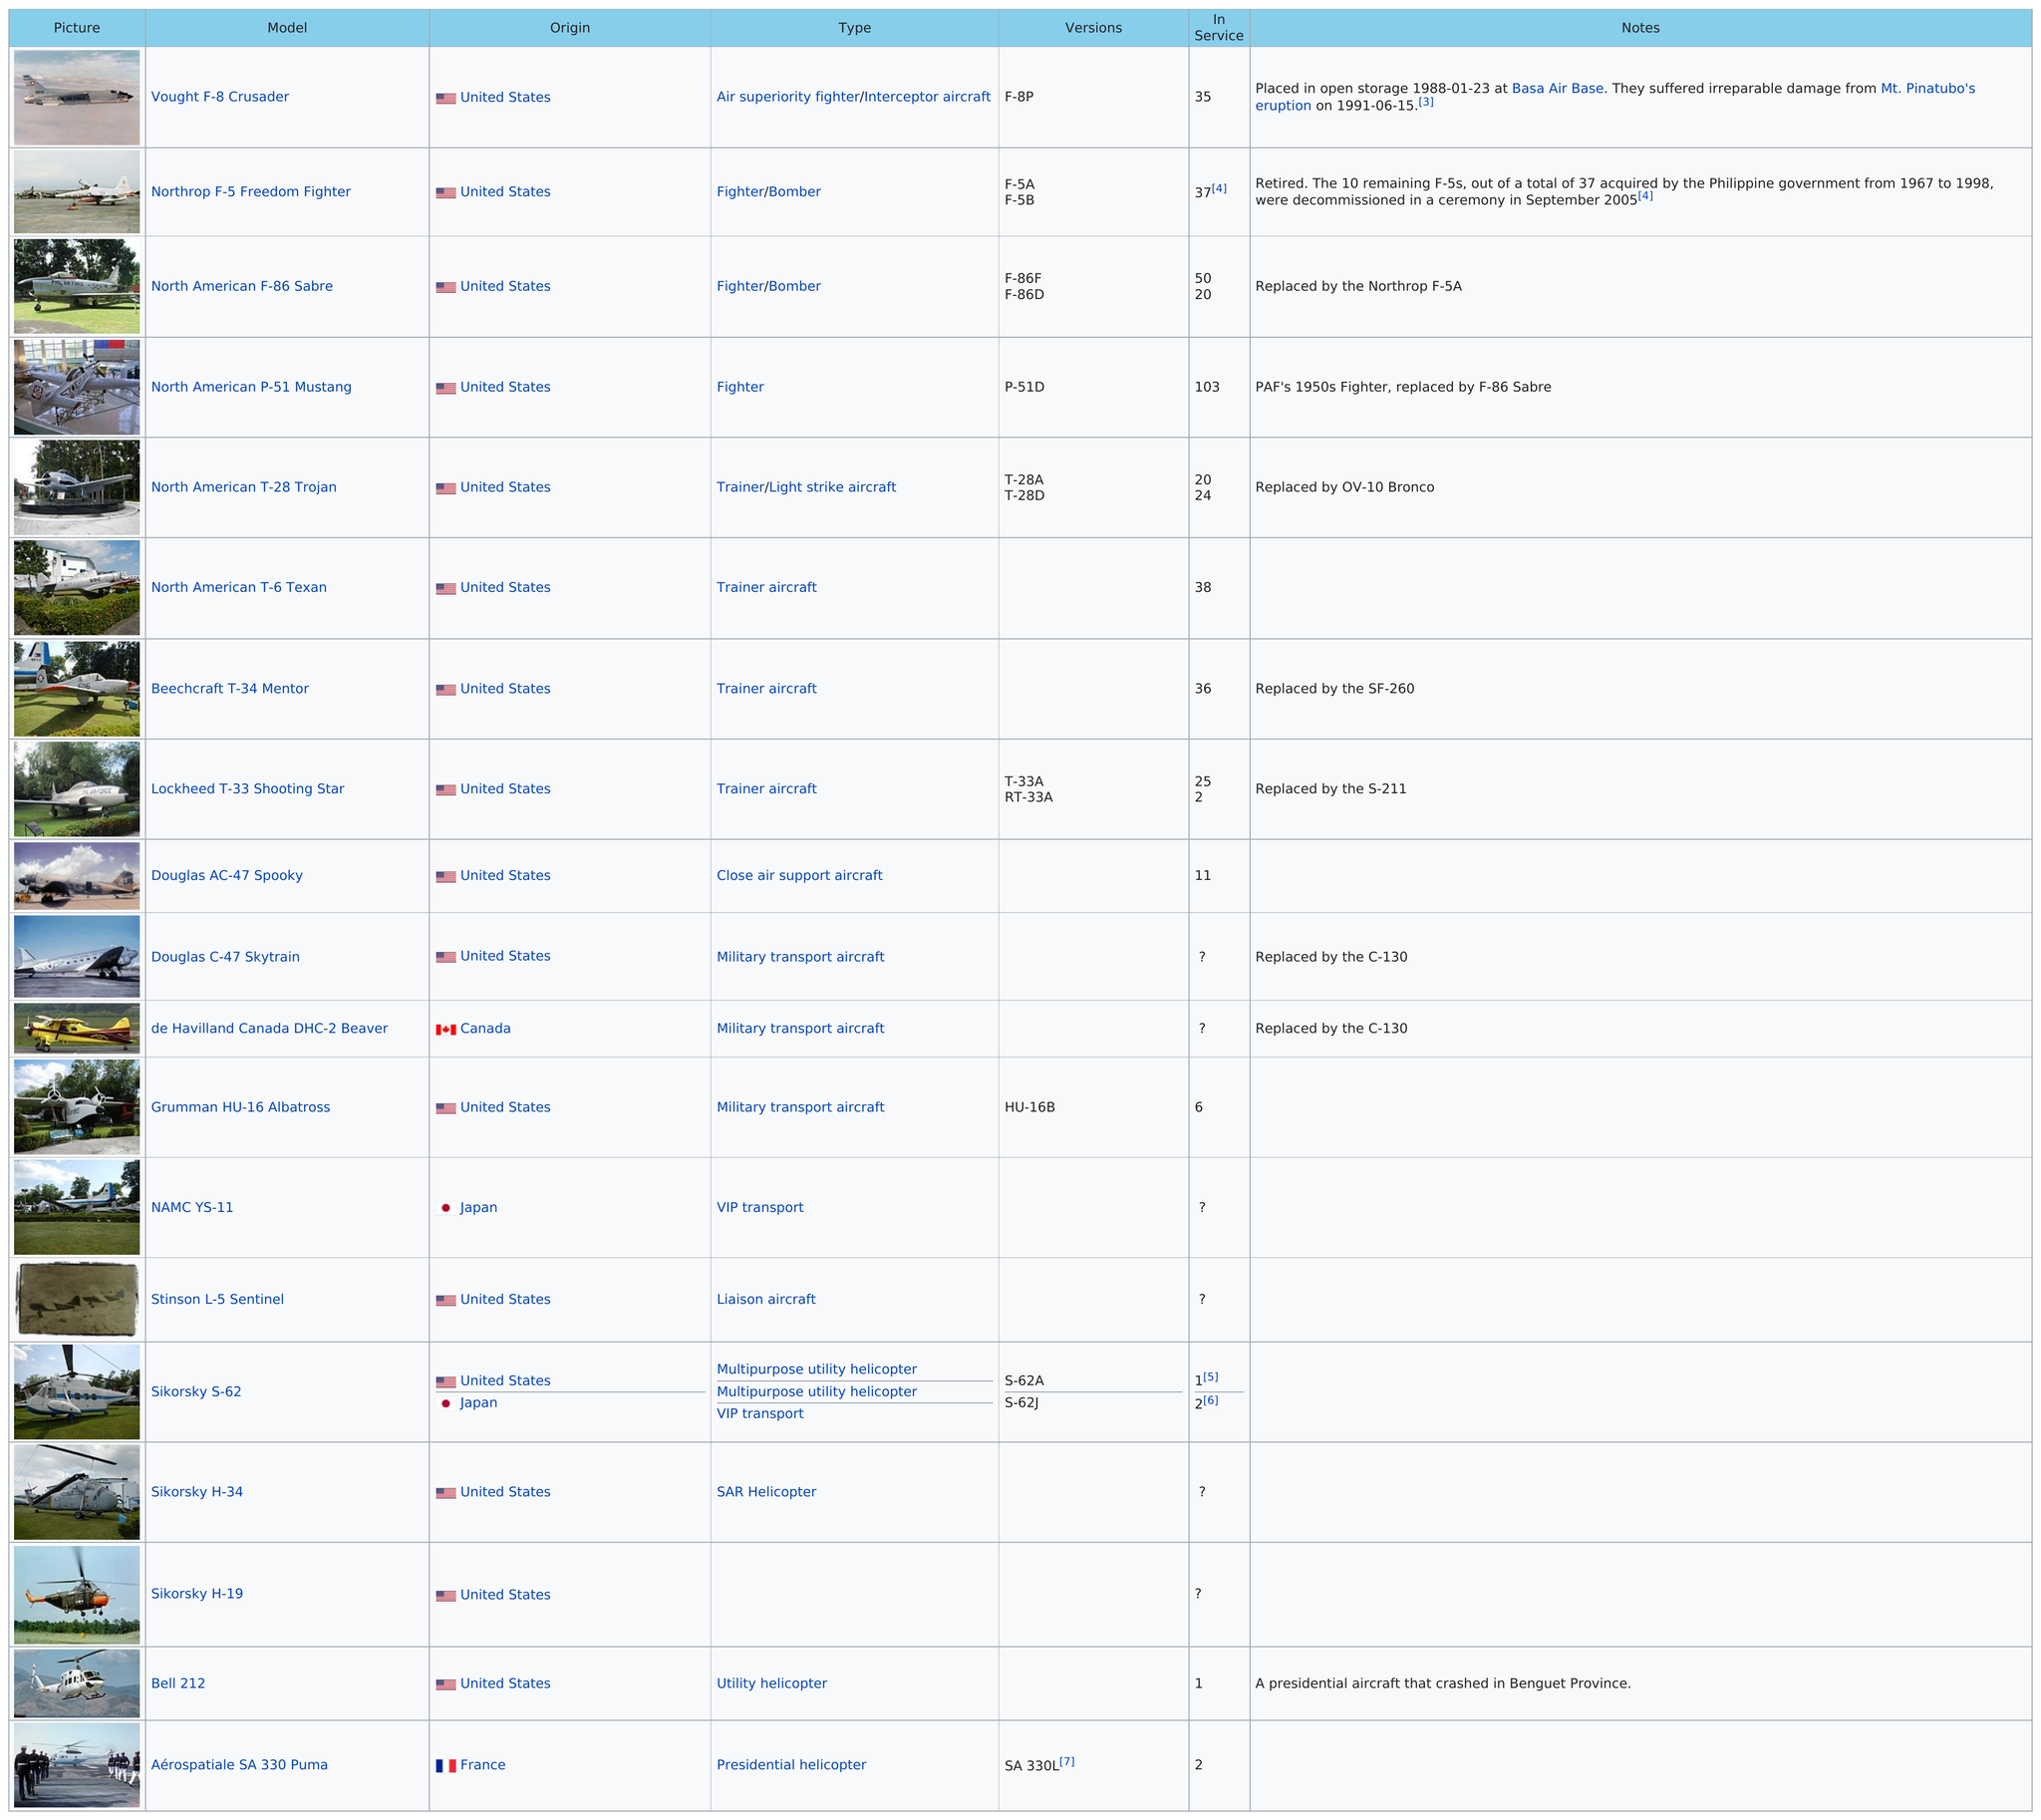Identify some key points in this picture. The North American T-28 Trojan model is above 6 Texan in terms of its specifications. After the Douglas C-47 Skytrain and the De Havilland Canada DHC-2 Beaver were replaced, they were succeeded by the C-130 model. The United States has the largest number of aircraft listed compared to any other country. France is the country that has the latest listed aircraft. The Vought F-8 Crusader was a model aircraft that was operable before the Mt. Pinatubo eruption, but the subsequent damage caused by the eruption was deemed irreparable. 